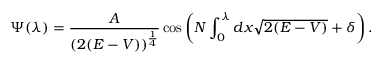<formula> <loc_0><loc_0><loc_500><loc_500>\Psi ( \lambda ) = \frac { A } { ( 2 ( E - V ) ) ^ { \frac { 1 } { 4 } } } \cos \left ( N \int _ { 0 } ^ { \lambda } d x \sqrt { 2 ( E - V ) } + \delta \right ) .</formula> 